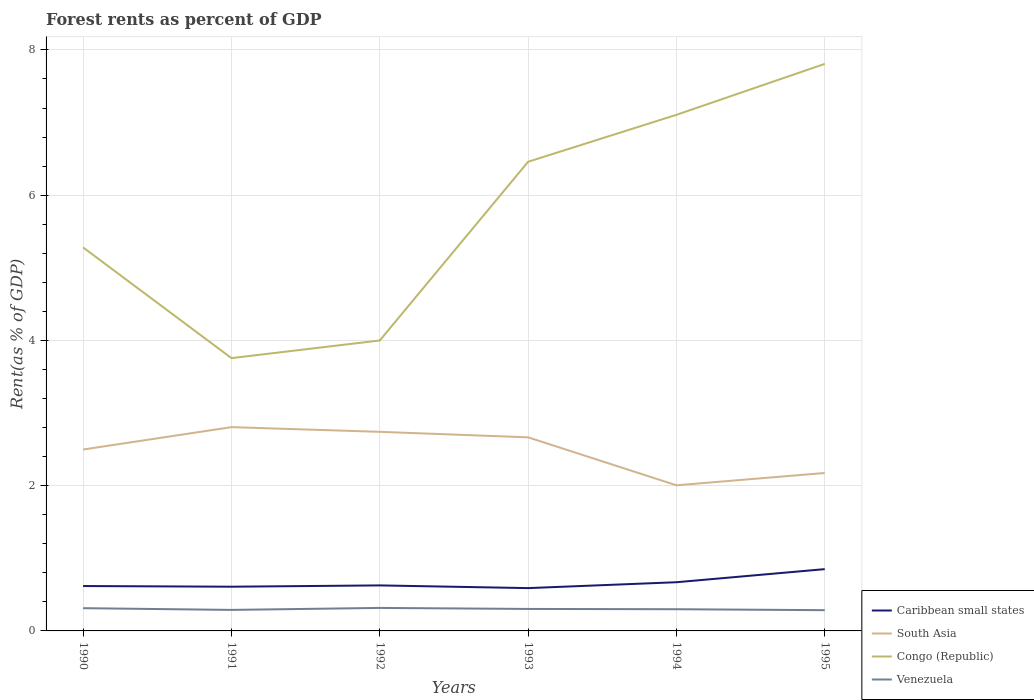How many different coloured lines are there?
Your answer should be compact. 4. Is the number of lines equal to the number of legend labels?
Provide a succinct answer. Yes. Across all years, what is the maximum forest rent in Congo (Republic)?
Make the answer very short. 3.76. What is the total forest rent in Congo (Republic) in the graph?
Ensure brevity in your answer.  -0.65. What is the difference between the highest and the second highest forest rent in Caribbean small states?
Provide a succinct answer. 0.26. How many lines are there?
Offer a terse response. 4. What is the difference between two consecutive major ticks on the Y-axis?
Offer a very short reply. 2. Where does the legend appear in the graph?
Make the answer very short. Bottom right. How many legend labels are there?
Offer a very short reply. 4. What is the title of the graph?
Ensure brevity in your answer.  Forest rents as percent of GDP. Does "Chile" appear as one of the legend labels in the graph?
Give a very brief answer. No. What is the label or title of the Y-axis?
Your answer should be compact. Rent(as % of GDP). What is the Rent(as % of GDP) of Caribbean small states in 1990?
Offer a terse response. 0.62. What is the Rent(as % of GDP) in South Asia in 1990?
Keep it short and to the point. 2.5. What is the Rent(as % of GDP) of Congo (Republic) in 1990?
Give a very brief answer. 5.28. What is the Rent(as % of GDP) in Venezuela in 1990?
Your answer should be compact. 0.31. What is the Rent(as % of GDP) in Caribbean small states in 1991?
Provide a succinct answer. 0.61. What is the Rent(as % of GDP) of South Asia in 1991?
Your response must be concise. 2.81. What is the Rent(as % of GDP) in Congo (Republic) in 1991?
Your answer should be very brief. 3.76. What is the Rent(as % of GDP) of Venezuela in 1991?
Offer a very short reply. 0.29. What is the Rent(as % of GDP) of Caribbean small states in 1992?
Your answer should be very brief. 0.63. What is the Rent(as % of GDP) in South Asia in 1992?
Ensure brevity in your answer.  2.74. What is the Rent(as % of GDP) in Congo (Republic) in 1992?
Make the answer very short. 4. What is the Rent(as % of GDP) of Venezuela in 1992?
Ensure brevity in your answer.  0.32. What is the Rent(as % of GDP) in Caribbean small states in 1993?
Ensure brevity in your answer.  0.59. What is the Rent(as % of GDP) in South Asia in 1993?
Make the answer very short. 2.67. What is the Rent(as % of GDP) of Congo (Republic) in 1993?
Your answer should be compact. 6.46. What is the Rent(as % of GDP) of Venezuela in 1993?
Give a very brief answer. 0.3. What is the Rent(as % of GDP) of Caribbean small states in 1994?
Keep it short and to the point. 0.67. What is the Rent(as % of GDP) in South Asia in 1994?
Offer a very short reply. 2.01. What is the Rent(as % of GDP) of Congo (Republic) in 1994?
Offer a very short reply. 7.11. What is the Rent(as % of GDP) in Venezuela in 1994?
Your response must be concise. 0.3. What is the Rent(as % of GDP) in Caribbean small states in 1995?
Ensure brevity in your answer.  0.85. What is the Rent(as % of GDP) in South Asia in 1995?
Offer a terse response. 2.17. What is the Rent(as % of GDP) of Congo (Republic) in 1995?
Provide a short and direct response. 7.81. What is the Rent(as % of GDP) of Venezuela in 1995?
Make the answer very short. 0.29. Across all years, what is the maximum Rent(as % of GDP) of Caribbean small states?
Ensure brevity in your answer.  0.85. Across all years, what is the maximum Rent(as % of GDP) in South Asia?
Your answer should be compact. 2.81. Across all years, what is the maximum Rent(as % of GDP) in Congo (Republic)?
Your answer should be compact. 7.81. Across all years, what is the maximum Rent(as % of GDP) of Venezuela?
Your answer should be compact. 0.32. Across all years, what is the minimum Rent(as % of GDP) in Caribbean small states?
Make the answer very short. 0.59. Across all years, what is the minimum Rent(as % of GDP) in South Asia?
Make the answer very short. 2.01. Across all years, what is the minimum Rent(as % of GDP) in Congo (Republic)?
Ensure brevity in your answer.  3.76. Across all years, what is the minimum Rent(as % of GDP) of Venezuela?
Offer a terse response. 0.29. What is the total Rent(as % of GDP) of Caribbean small states in the graph?
Give a very brief answer. 3.96. What is the total Rent(as % of GDP) of South Asia in the graph?
Offer a very short reply. 14.89. What is the total Rent(as % of GDP) in Congo (Republic) in the graph?
Offer a very short reply. 34.41. What is the total Rent(as % of GDP) in Venezuela in the graph?
Provide a succinct answer. 1.81. What is the difference between the Rent(as % of GDP) of Caribbean small states in 1990 and that in 1991?
Give a very brief answer. 0.01. What is the difference between the Rent(as % of GDP) of South Asia in 1990 and that in 1991?
Ensure brevity in your answer.  -0.31. What is the difference between the Rent(as % of GDP) of Congo (Republic) in 1990 and that in 1991?
Provide a succinct answer. 1.52. What is the difference between the Rent(as % of GDP) of Venezuela in 1990 and that in 1991?
Provide a succinct answer. 0.02. What is the difference between the Rent(as % of GDP) in Caribbean small states in 1990 and that in 1992?
Provide a succinct answer. -0.01. What is the difference between the Rent(as % of GDP) in South Asia in 1990 and that in 1992?
Keep it short and to the point. -0.24. What is the difference between the Rent(as % of GDP) in Congo (Republic) in 1990 and that in 1992?
Provide a succinct answer. 1.28. What is the difference between the Rent(as % of GDP) in Venezuela in 1990 and that in 1992?
Offer a very short reply. -0. What is the difference between the Rent(as % of GDP) of Caribbean small states in 1990 and that in 1993?
Provide a short and direct response. 0.03. What is the difference between the Rent(as % of GDP) in South Asia in 1990 and that in 1993?
Offer a very short reply. -0.17. What is the difference between the Rent(as % of GDP) in Congo (Republic) in 1990 and that in 1993?
Make the answer very short. -1.18. What is the difference between the Rent(as % of GDP) of Venezuela in 1990 and that in 1993?
Your answer should be compact. 0.01. What is the difference between the Rent(as % of GDP) in Caribbean small states in 1990 and that in 1994?
Your answer should be compact. -0.05. What is the difference between the Rent(as % of GDP) in South Asia in 1990 and that in 1994?
Offer a very short reply. 0.49. What is the difference between the Rent(as % of GDP) of Congo (Republic) in 1990 and that in 1994?
Ensure brevity in your answer.  -1.83. What is the difference between the Rent(as % of GDP) in Venezuela in 1990 and that in 1994?
Your answer should be compact. 0.01. What is the difference between the Rent(as % of GDP) in Caribbean small states in 1990 and that in 1995?
Provide a short and direct response. -0.23. What is the difference between the Rent(as % of GDP) in South Asia in 1990 and that in 1995?
Give a very brief answer. 0.32. What is the difference between the Rent(as % of GDP) of Congo (Republic) in 1990 and that in 1995?
Provide a succinct answer. -2.53. What is the difference between the Rent(as % of GDP) in Venezuela in 1990 and that in 1995?
Provide a succinct answer. 0.03. What is the difference between the Rent(as % of GDP) of Caribbean small states in 1991 and that in 1992?
Your response must be concise. -0.02. What is the difference between the Rent(as % of GDP) of South Asia in 1991 and that in 1992?
Offer a terse response. 0.06. What is the difference between the Rent(as % of GDP) in Congo (Republic) in 1991 and that in 1992?
Your answer should be compact. -0.24. What is the difference between the Rent(as % of GDP) in Venezuela in 1991 and that in 1992?
Provide a succinct answer. -0.03. What is the difference between the Rent(as % of GDP) of Caribbean small states in 1991 and that in 1993?
Offer a terse response. 0.02. What is the difference between the Rent(as % of GDP) in South Asia in 1991 and that in 1993?
Your answer should be very brief. 0.14. What is the difference between the Rent(as % of GDP) in Congo (Republic) in 1991 and that in 1993?
Offer a terse response. -2.7. What is the difference between the Rent(as % of GDP) in Venezuela in 1991 and that in 1993?
Offer a terse response. -0.01. What is the difference between the Rent(as % of GDP) in Caribbean small states in 1991 and that in 1994?
Offer a very short reply. -0.06. What is the difference between the Rent(as % of GDP) in South Asia in 1991 and that in 1994?
Provide a succinct answer. 0.8. What is the difference between the Rent(as % of GDP) in Congo (Republic) in 1991 and that in 1994?
Make the answer very short. -3.35. What is the difference between the Rent(as % of GDP) of Venezuela in 1991 and that in 1994?
Offer a terse response. -0.01. What is the difference between the Rent(as % of GDP) in Caribbean small states in 1991 and that in 1995?
Offer a very short reply. -0.24. What is the difference between the Rent(as % of GDP) in South Asia in 1991 and that in 1995?
Your answer should be compact. 0.63. What is the difference between the Rent(as % of GDP) in Congo (Republic) in 1991 and that in 1995?
Make the answer very short. -4.05. What is the difference between the Rent(as % of GDP) of Venezuela in 1991 and that in 1995?
Provide a succinct answer. 0. What is the difference between the Rent(as % of GDP) of Caribbean small states in 1992 and that in 1993?
Give a very brief answer. 0.04. What is the difference between the Rent(as % of GDP) of South Asia in 1992 and that in 1993?
Make the answer very short. 0.08. What is the difference between the Rent(as % of GDP) of Congo (Republic) in 1992 and that in 1993?
Give a very brief answer. -2.46. What is the difference between the Rent(as % of GDP) in Venezuela in 1992 and that in 1993?
Your answer should be very brief. 0.01. What is the difference between the Rent(as % of GDP) in Caribbean small states in 1992 and that in 1994?
Offer a very short reply. -0.04. What is the difference between the Rent(as % of GDP) of South Asia in 1992 and that in 1994?
Your answer should be compact. 0.74. What is the difference between the Rent(as % of GDP) in Congo (Republic) in 1992 and that in 1994?
Ensure brevity in your answer.  -3.11. What is the difference between the Rent(as % of GDP) of Venezuela in 1992 and that in 1994?
Give a very brief answer. 0.02. What is the difference between the Rent(as % of GDP) of Caribbean small states in 1992 and that in 1995?
Your response must be concise. -0.22. What is the difference between the Rent(as % of GDP) in South Asia in 1992 and that in 1995?
Provide a short and direct response. 0.57. What is the difference between the Rent(as % of GDP) of Congo (Republic) in 1992 and that in 1995?
Offer a terse response. -3.81. What is the difference between the Rent(as % of GDP) in Venezuela in 1992 and that in 1995?
Ensure brevity in your answer.  0.03. What is the difference between the Rent(as % of GDP) of Caribbean small states in 1993 and that in 1994?
Provide a succinct answer. -0.08. What is the difference between the Rent(as % of GDP) in South Asia in 1993 and that in 1994?
Ensure brevity in your answer.  0.66. What is the difference between the Rent(as % of GDP) in Congo (Republic) in 1993 and that in 1994?
Your response must be concise. -0.65. What is the difference between the Rent(as % of GDP) in Venezuela in 1993 and that in 1994?
Offer a terse response. 0. What is the difference between the Rent(as % of GDP) in Caribbean small states in 1993 and that in 1995?
Make the answer very short. -0.26. What is the difference between the Rent(as % of GDP) in South Asia in 1993 and that in 1995?
Provide a succinct answer. 0.49. What is the difference between the Rent(as % of GDP) in Congo (Republic) in 1993 and that in 1995?
Provide a succinct answer. -1.35. What is the difference between the Rent(as % of GDP) in Venezuela in 1993 and that in 1995?
Ensure brevity in your answer.  0.02. What is the difference between the Rent(as % of GDP) of Caribbean small states in 1994 and that in 1995?
Provide a succinct answer. -0.18. What is the difference between the Rent(as % of GDP) of South Asia in 1994 and that in 1995?
Give a very brief answer. -0.17. What is the difference between the Rent(as % of GDP) of Congo (Republic) in 1994 and that in 1995?
Offer a very short reply. -0.7. What is the difference between the Rent(as % of GDP) of Venezuela in 1994 and that in 1995?
Provide a short and direct response. 0.01. What is the difference between the Rent(as % of GDP) in Caribbean small states in 1990 and the Rent(as % of GDP) in South Asia in 1991?
Your answer should be compact. -2.19. What is the difference between the Rent(as % of GDP) of Caribbean small states in 1990 and the Rent(as % of GDP) of Congo (Republic) in 1991?
Give a very brief answer. -3.14. What is the difference between the Rent(as % of GDP) in Caribbean small states in 1990 and the Rent(as % of GDP) in Venezuela in 1991?
Provide a short and direct response. 0.33. What is the difference between the Rent(as % of GDP) in South Asia in 1990 and the Rent(as % of GDP) in Congo (Republic) in 1991?
Offer a very short reply. -1.26. What is the difference between the Rent(as % of GDP) in South Asia in 1990 and the Rent(as % of GDP) in Venezuela in 1991?
Offer a terse response. 2.21. What is the difference between the Rent(as % of GDP) of Congo (Republic) in 1990 and the Rent(as % of GDP) of Venezuela in 1991?
Your response must be concise. 4.99. What is the difference between the Rent(as % of GDP) of Caribbean small states in 1990 and the Rent(as % of GDP) of South Asia in 1992?
Provide a short and direct response. -2.12. What is the difference between the Rent(as % of GDP) in Caribbean small states in 1990 and the Rent(as % of GDP) in Congo (Republic) in 1992?
Offer a terse response. -3.38. What is the difference between the Rent(as % of GDP) in Caribbean small states in 1990 and the Rent(as % of GDP) in Venezuela in 1992?
Your response must be concise. 0.3. What is the difference between the Rent(as % of GDP) of South Asia in 1990 and the Rent(as % of GDP) of Congo (Republic) in 1992?
Make the answer very short. -1.5. What is the difference between the Rent(as % of GDP) in South Asia in 1990 and the Rent(as % of GDP) in Venezuela in 1992?
Offer a terse response. 2.18. What is the difference between the Rent(as % of GDP) of Congo (Republic) in 1990 and the Rent(as % of GDP) of Venezuela in 1992?
Keep it short and to the point. 4.96. What is the difference between the Rent(as % of GDP) of Caribbean small states in 1990 and the Rent(as % of GDP) of South Asia in 1993?
Give a very brief answer. -2.05. What is the difference between the Rent(as % of GDP) of Caribbean small states in 1990 and the Rent(as % of GDP) of Congo (Republic) in 1993?
Keep it short and to the point. -5.84. What is the difference between the Rent(as % of GDP) of Caribbean small states in 1990 and the Rent(as % of GDP) of Venezuela in 1993?
Ensure brevity in your answer.  0.32. What is the difference between the Rent(as % of GDP) in South Asia in 1990 and the Rent(as % of GDP) in Congo (Republic) in 1993?
Your answer should be very brief. -3.96. What is the difference between the Rent(as % of GDP) in South Asia in 1990 and the Rent(as % of GDP) in Venezuela in 1993?
Offer a terse response. 2.2. What is the difference between the Rent(as % of GDP) of Congo (Republic) in 1990 and the Rent(as % of GDP) of Venezuela in 1993?
Offer a terse response. 4.98. What is the difference between the Rent(as % of GDP) of Caribbean small states in 1990 and the Rent(as % of GDP) of South Asia in 1994?
Your answer should be compact. -1.39. What is the difference between the Rent(as % of GDP) in Caribbean small states in 1990 and the Rent(as % of GDP) in Congo (Republic) in 1994?
Offer a very short reply. -6.49. What is the difference between the Rent(as % of GDP) in Caribbean small states in 1990 and the Rent(as % of GDP) in Venezuela in 1994?
Your answer should be compact. 0.32. What is the difference between the Rent(as % of GDP) of South Asia in 1990 and the Rent(as % of GDP) of Congo (Republic) in 1994?
Your answer should be very brief. -4.61. What is the difference between the Rent(as % of GDP) of South Asia in 1990 and the Rent(as % of GDP) of Venezuela in 1994?
Make the answer very short. 2.2. What is the difference between the Rent(as % of GDP) of Congo (Republic) in 1990 and the Rent(as % of GDP) of Venezuela in 1994?
Your answer should be compact. 4.98. What is the difference between the Rent(as % of GDP) in Caribbean small states in 1990 and the Rent(as % of GDP) in South Asia in 1995?
Give a very brief answer. -1.56. What is the difference between the Rent(as % of GDP) of Caribbean small states in 1990 and the Rent(as % of GDP) of Congo (Republic) in 1995?
Make the answer very short. -7.19. What is the difference between the Rent(as % of GDP) of Caribbean small states in 1990 and the Rent(as % of GDP) of Venezuela in 1995?
Offer a terse response. 0.33. What is the difference between the Rent(as % of GDP) of South Asia in 1990 and the Rent(as % of GDP) of Congo (Republic) in 1995?
Your response must be concise. -5.31. What is the difference between the Rent(as % of GDP) in South Asia in 1990 and the Rent(as % of GDP) in Venezuela in 1995?
Make the answer very short. 2.21. What is the difference between the Rent(as % of GDP) in Congo (Republic) in 1990 and the Rent(as % of GDP) in Venezuela in 1995?
Your answer should be compact. 4.99. What is the difference between the Rent(as % of GDP) of Caribbean small states in 1991 and the Rent(as % of GDP) of South Asia in 1992?
Provide a short and direct response. -2.13. What is the difference between the Rent(as % of GDP) in Caribbean small states in 1991 and the Rent(as % of GDP) in Congo (Republic) in 1992?
Give a very brief answer. -3.39. What is the difference between the Rent(as % of GDP) of Caribbean small states in 1991 and the Rent(as % of GDP) of Venezuela in 1992?
Provide a succinct answer. 0.29. What is the difference between the Rent(as % of GDP) in South Asia in 1991 and the Rent(as % of GDP) in Congo (Republic) in 1992?
Keep it short and to the point. -1.19. What is the difference between the Rent(as % of GDP) in South Asia in 1991 and the Rent(as % of GDP) in Venezuela in 1992?
Your answer should be compact. 2.49. What is the difference between the Rent(as % of GDP) in Congo (Republic) in 1991 and the Rent(as % of GDP) in Venezuela in 1992?
Your response must be concise. 3.44. What is the difference between the Rent(as % of GDP) of Caribbean small states in 1991 and the Rent(as % of GDP) of South Asia in 1993?
Ensure brevity in your answer.  -2.06. What is the difference between the Rent(as % of GDP) in Caribbean small states in 1991 and the Rent(as % of GDP) in Congo (Republic) in 1993?
Your answer should be very brief. -5.85. What is the difference between the Rent(as % of GDP) of Caribbean small states in 1991 and the Rent(as % of GDP) of Venezuela in 1993?
Provide a succinct answer. 0.31. What is the difference between the Rent(as % of GDP) of South Asia in 1991 and the Rent(as % of GDP) of Congo (Republic) in 1993?
Give a very brief answer. -3.65. What is the difference between the Rent(as % of GDP) in South Asia in 1991 and the Rent(as % of GDP) in Venezuela in 1993?
Provide a short and direct response. 2.5. What is the difference between the Rent(as % of GDP) of Congo (Republic) in 1991 and the Rent(as % of GDP) of Venezuela in 1993?
Keep it short and to the point. 3.45. What is the difference between the Rent(as % of GDP) of Caribbean small states in 1991 and the Rent(as % of GDP) of South Asia in 1994?
Your answer should be very brief. -1.4. What is the difference between the Rent(as % of GDP) of Caribbean small states in 1991 and the Rent(as % of GDP) of Congo (Republic) in 1994?
Provide a short and direct response. -6.5. What is the difference between the Rent(as % of GDP) of Caribbean small states in 1991 and the Rent(as % of GDP) of Venezuela in 1994?
Your answer should be very brief. 0.31. What is the difference between the Rent(as % of GDP) in South Asia in 1991 and the Rent(as % of GDP) in Congo (Republic) in 1994?
Provide a short and direct response. -4.3. What is the difference between the Rent(as % of GDP) of South Asia in 1991 and the Rent(as % of GDP) of Venezuela in 1994?
Make the answer very short. 2.51. What is the difference between the Rent(as % of GDP) of Congo (Republic) in 1991 and the Rent(as % of GDP) of Venezuela in 1994?
Your answer should be compact. 3.46. What is the difference between the Rent(as % of GDP) of Caribbean small states in 1991 and the Rent(as % of GDP) of South Asia in 1995?
Offer a very short reply. -1.57. What is the difference between the Rent(as % of GDP) of Caribbean small states in 1991 and the Rent(as % of GDP) of Congo (Republic) in 1995?
Your answer should be very brief. -7.2. What is the difference between the Rent(as % of GDP) in Caribbean small states in 1991 and the Rent(as % of GDP) in Venezuela in 1995?
Offer a terse response. 0.32. What is the difference between the Rent(as % of GDP) of South Asia in 1991 and the Rent(as % of GDP) of Congo (Republic) in 1995?
Make the answer very short. -5. What is the difference between the Rent(as % of GDP) of South Asia in 1991 and the Rent(as % of GDP) of Venezuela in 1995?
Give a very brief answer. 2.52. What is the difference between the Rent(as % of GDP) in Congo (Republic) in 1991 and the Rent(as % of GDP) in Venezuela in 1995?
Make the answer very short. 3.47. What is the difference between the Rent(as % of GDP) of Caribbean small states in 1992 and the Rent(as % of GDP) of South Asia in 1993?
Give a very brief answer. -2.04. What is the difference between the Rent(as % of GDP) of Caribbean small states in 1992 and the Rent(as % of GDP) of Congo (Republic) in 1993?
Offer a terse response. -5.83. What is the difference between the Rent(as % of GDP) of Caribbean small states in 1992 and the Rent(as % of GDP) of Venezuela in 1993?
Your answer should be very brief. 0.32. What is the difference between the Rent(as % of GDP) in South Asia in 1992 and the Rent(as % of GDP) in Congo (Republic) in 1993?
Give a very brief answer. -3.72. What is the difference between the Rent(as % of GDP) of South Asia in 1992 and the Rent(as % of GDP) of Venezuela in 1993?
Your answer should be very brief. 2.44. What is the difference between the Rent(as % of GDP) of Congo (Republic) in 1992 and the Rent(as % of GDP) of Venezuela in 1993?
Give a very brief answer. 3.7. What is the difference between the Rent(as % of GDP) of Caribbean small states in 1992 and the Rent(as % of GDP) of South Asia in 1994?
Provide a short and direct response. -1.38. What is the difference between the Rent(as % of GDP) in Caribbean small states in 1992 and the Rent(as % of GDP) in Congo (Republic) in 1994?
Provide a succinct answer. -6.48. What is the difference between the Rent(as % of GDP) of Caribbean small states in 1992 and the Rent(as % of GDP) of Venezuela in 1994?
Keep it short and to the point. 0.33. What is the difference between the Rent(as % of GDP) of South Asia in 1992 and the Rent(as % of GDP) of Congo (Republic) in 1994?
Provide a succinct answer. -4.37. What is the difference between the Rent(as % of GDP) in South Asia in 1992 and the Rent(as % of GDP) in Venezuela in 1994?
Your response must be concise. 2.44. What is the difference between the Rent(as % of GDP) in Congo (Republic) in 1992 and the Rent(as % of GDP) in Venezuela in 1994?
Offer a terse response. 3.7. What is the difference between the Rent(as % of GDP) in Caribbean small states in 1992 and the Rent(as % of GDP) in South Asia in 1995?
Give a very brief answer. -1.55. What is the difference between the Rent(as % of GDP) of Caribbean small states in 1992 and the Rent(as % of GDP) of Congo (Republic) in 1995?
Your answer should be very brief. -7.18. What is the difference between the Rent(as % of GDP) of Caribbean small states in 1992 and the Rent(as % of GDP) of Venezuela in 1995?
Your response must be concise. 0.34. What is the difference between the Rent(as % of GDP) in South Asia in 1992 and the Rent(as % of GDP) in Congo (Republic) in 1995?
Your answer should be compact. -5.07. What is the difference between the Rent(as % of GDP) of South Asia in 1992 and the Rent(as % of GDP) of Venezuela in 1995?
Offer a very short reply. 2.46. What is the difference between the Rent(as % of GDP) in Congo (Republic) in 1992 and the Rent(as % of GDP) in Venezuela in 1995?
Ensure brevity in your answer.  3.71. What is the difference between the Rent(as % of GDP) of Caribbean small states in 1993 and the Rent(as % of GDP) of South Asia in 1994?
Provide a succinct answer. -1.42. What is the difference between the Rent(as % of GDP) of Caribbean small states in 1993 and the Rent(as % of GDP) of Congo (Republic) in 1994?
Give a very brief answer. -6.52. What is the difference between the Rent(as % of GDP) in Caribbean small states in 1993 and the Rent(as % of GDP) in Venezuela in 1994?
Give a very brief answer. 0.29. What is the difference between the Rent(as % of GDP) in South Asia in 1993 and the Rent(as % of GDP) in Congo (Republic) in 1994?
Your response must be concise. -4.44. What is the difference between the Rent(as % of GDP) in South Asia in 1993 and the Rent(as % of GDP) in Venezuela in 1994?
Provide a short and direct response. 2.37. What is the difference between the Rent(as % of GDP) of Congo (Republic) in 1993 and the Rent(as % of GDP) of Venezuela in 1994?
Your answer should be very brief. 6.16. What is the difference between the Rent(as % of GDP) in Caribbean small states in 1993 and the Rent(as % of GDP) in South Asia in 1995?
Your answer should be compact. -1.59. What is the difference between the Rent(as % of GDP) in Caribbean small states in 1993 and the Rent(as % of GDP) in Congo (Republic) in 1995?
Keep it short and to the point. -7.22. What is the difference between the Rent(as % of GDP) in Caribbean small states in 1993 and the Rent(as % of GDP) in Venezuela in 1995?
Your answer should be compact. 0.3. What is the difference between the Rent(as % of GDP) of South Asia in 1993 and the Rent(as % of GDP) of Congo (Republic) in 1995?
Your answer should be very brief. -5.14. What is the difference between the Rent(as % of GDP) in South Asia in 1993 and the Rent(as % of GDP) in Venezuela in 1995?
Provide a short and direct response. 2.38. What is the difference between the Rent(as % of GDP) in Congo (Republic) in 1993 and the Rent(as % of GDP) in Venezuela in 1995?
Keep it short and to the point. 6.17. What is the difference between the Rent(as % of GDP) of Caribbean small states in 1994 and the Rent(as % of GDP) of South Asia in 1995?
Ensure brevity in your answer.  -1.5. What is the difference between the Rent(as % of GDP) in Caribbean small states in 1994 and the Rent(as % of GDP) in Congo (Republic) in 1995?
Your answer should be very brief. -7.14. What is the difference between the Rent(as % of GDP) in Caribbean small states in 1994 and the Rent(as % of GDP) in Venezuela in 1995?
Provide a succinct answer. 0.38. What is the difference between the Rent(as % of GDP) in South Asia in 1994 and the Rent(as % of GDP) in Congo (Republic) in 1995?
Offer a terse response. -5.8. What is the difference between the Rent(as % of GDP) in South Asia in 1994 and the Rent(as % of GDP) in Venezuela in 1995?
Offer a terse response. 1.72. What is the difference between the Rent(as % of GDP) in Congo (Republic) in 1994 and the Rent(as % of GDP) in Venezuela in 1995?
Make the answer very short. 6.82. What is the average Rent(as % of GDP) of Caribbean small states per year?
Provide a short and direct response. 0.66. What is the average Rent(as % of GDP) of South Asia per year?
Keep it short and to the point. 2.48. What is the average Rent(as % of GDP) of Congo (Republic) per year?
Provide a succinct answer. 5.74. What is the average Rent(as % of GDP) in Venezuela per year?
Your response must be concise. 0.3. In the year 1990, what is the difference between the Rent(as % of GDP) of Caribbean small states and Rent(as % of GDP) of South Asia?
Keep it short and to the point. -1.88. In the year 1990, what is the difference between the Rent(as % of GDP) in Caribbean small states and Rent(as % of GDP) in Congo (Republic)?
Give a very brief answer. -4.66. In the year 1990, what is the difference between the Rent(as % of GDP) in Caribbean small states and Rent(as % of GDP) in Venezuela?
Make the answer very short. 0.3. In the year 1990, what is the difference between the Rent(as % of GDP) of South Asia and Rent(as % of GDP) of Congo (Republic)?
Provide a succinct answer. -2.78. In the year 1990, what is the difference between the Rent(as % of GDP) in South Asia and Rent(as % of GDP) in Venezuela?
Provide a short and direct response. 2.18. In the year 1990, what is the difference between the Rent(as % of GDP) of Congo (Republic) and Rent(as % of GDP) of Venezuela?
Your answer should be compact. 4.97. In the year 1991, what is the difference between the Rent(as % of GDP) of Caribbean small states and Rent(as % of GDP) of South Asia?
Your answer should be very brief. -2.2. In the year 1991, what is the difference between the Rent(as % of GDP) in Caribbean small states and Rent(as % of GDP) in Congo (Republic)?
Give a very brief answer. -3.15. In the year 1991, what is the difference between the Rent(as % of GDP) of Caribbean small states and Rent(as % of GDP) of Venezuela?
Your answer should be very brief. 0.32. In the year 1991, what is the difference between the Rent(as % of GDP) of South Asia and Rent(as % of GDP) of Congo (Republic)?
Offer a terse response. -0.95. In the year 1991, what is the difference between the Rent(as % of GDP) of South Asia and Rent(as % of GDP) of Venezuela?
Provide a succinct answer. 2.52. In the year 1991, what is the difference between the Rent(as % of GDP) of Congo (Republic) and Rent(as % of GDP) of Venezuela?
Your answer should be compact. 3.47. In the year 1992, what is the difference between the Rent(as % of GDP) in Caribbean small states and Rent(as % of GDP) in South Asia?
Your answer should be very brief. -2.11. In the year 1992, what is the difference between the Rent(as % of GDP) of Caribbean small states and Rent(as % of GDP) of Congo (Republic)?
Provide a succinct answer. -3.37. In the year 1992, what is the difference between the Rent(as % of GDP) of Caribbean small states and Rent(as % of GDP) of Venezuela?
Offer a very short reply. 0.31. In the year 1992, what is the difference between the Rent(as % of GDP) in South Asia and Rent(as % of GDP) in Congo (Republic)?
Your answer should be very brief. -1.26. In the year 1992, what is the difference between the Rent(as % of GDP) in South Asia and Rent(as % of GDP) in Venezuela?
Your answer should be compact. 2.42. In the year 1992, what is the difference between the Rent(as % of GDP) of Congo (Republic) and Rent(as % of GDP) of Venezuela?
Give a very brief answer. 3.68. In the year 1993, what is the difference between the Rent(as % of GDP) in Caribbean small states and Rent(as % of GDP) in South Asia?
Give a very brief answer. -2.08. In the year 1993, what is the difference between the Rent(as % of GDP) in Caribbean small states and Rent(as % of GDP) in Congo (Republic)?
Your answer should be very brief. -5.87. In the year 1993, what is the difference between the Rent(as % of GDP) of Caribbean small states and Rent(as % of GDP) of Venezuela?
Ensure brevity in your answer.  0.29. In the year 1993, what is the difference between the Rent(as % of GDP) in South Asia and Rent(as % of GDP) in Congo (Republic)?
Your answer should be very brief. -3.79. In the year 1993, what is the difference between the Rent(as % of GDP) in South Asia and Rent(as % of GDP) in Venezuela?
Make the answer very short. 2.36. In the year 1993, what is the difference between the Rent(as % of GDP) in Congo (Republic) and Rent(as % of GDP) in Venezuela?
Provide a short and direct response. 6.16. In the year 1994, what is the difference between the Rent(as % of GDP) of Caribbean small states and Rent(as % of GDP) of South Asia?
Your answer should be compact. -1.33. In the year 1994, what is the difference between the Rent(as % of GDP) in Caribbean small states and Rent(as % of GDP) in Congo (Republic)?
Your response must be concise. -6.44. In the year 1994, what is the difference between the Rent(as % of GDP) in Caribbean small states and Rent(as % of GDP) in Venezuela?
Offer a very short reply. 0.37. In the year 1994, what is the difference between the Rent(as % of GDP) of South Asia and Rent(as % of GDP) of Congo (Republic)?
Provide a succinct answer. -5.1. In the year 1994, what is the difference between the Rent(as % of GDP) of South Asia and Rent(as % of GDP) of Venezuela?
Ensure brevity in your answer.  1.71. In the year 1994, what is the difference between the Rent(as % of GDP) in Congo (Republic) and Rent(as % of GDP) in Venezuela?
Your answer should be very brief. 6.81. In the year 1995, what is the difference between the Rent(as % of GDP) in Caribbean small states and Rent(as % of GDP) in South Asia?
Your answer should be very brief. -1.32. In the year 1995, what is the difference between the Rent(as % of GDP) of Caribbean small states and Rent(as % of GDP) of Congo (Republic)?
Give a very brief answer. -6.96. In the year 1995, what is the difference between the Rent(as % of GDP) of Caribbean small states and Rent(as % of GDP) of Venezuela?
Give a very brief answer. 0.56. In the year 1995, what is the difference between the Rent(as % of GDP) of South Asia and Rent(as % of GDP) of Congo (Republic)?
Provide a succinct answer. -5.63. In the year 1995, what is the difference between the Rent(as % of GDP) of South Asia and Rent(as % of GDP) of Venezuela?
Your answer should be compact. 1.89. In the year 1995, what is the difference between the Rent(as % of GDP) in Congo (Republic) and Rent(as % of GDP) in Venezuela?
Offer a terse response. 7.52. What is the ratio of the Rent(as % of GDP) of Caribbean small states in 1990 to that in 1991?
Ensure brevity in your answer.  1.02. What is the ratio of the Rent(as % of GDP) in South Asia in 1990 to that in 1991?
Provide a succinct answer. 0.89. What is the ratio of the Rent(as % of GDP) in Congo (Republic) in 1990 to that in 1991?
Provide a succinct answer. 1.41. What is the ratio of the Rent(as % of GDP) in Venezuela in 1990 to that in 1991?
Give a very brief answer. 1.08. What is the ratio of the Rent(as % of GDP) of Caribbean small states in 1990 to that in 1992?
Offer a very short reply. 0.99. What is the ratio of the Rent(as % of GDP) in South Asia in 1990 to that in 1992?
Provide a short and direct response. 0.91. What is the ratio of the Rent(as % of GDP) in Congo (Republic) in 1990 to that in 1992?
Your answer should be very brief. 1.32. What is the ratio of the Rent(as % of GDP) in Caribbean small states in 1990 to that in 1993?
Provide a short and direct response. 1.05. What is the ratio of the Rent(as % of GDP) of South Asia in 1990 to that in 1993?
Your response must be concise. 0.94. What is the ratio of the Rent(as % of GDP) of Congo (Republic) in 1990 to that in 1993?
Make the answer very short. 0.82. What is the ratio of the Rent(as % of GDP) of Venezuela in 1990 to that in 1993?
Keep it short and to the point. 1.03. What is the ratio of the Rent(as % of GDP) of Caribbean small states in 1990 to that in 1994?
Your answer should be very brief. 0.92. What is the ratio of the Rent(as % of GDP) in South Asia in 1990 to that in 1994?
Your answer should be very brief. 1.25. What is the ratio of the Rent(as % of GDP) in Congo (Republic) in 1990 to that in 1994?
Keep it short and to the point. 0.74. What is the ratio of the Rent(as % of GDP) in Venezuela in 1990 to that in 1994?
Offer a terse response. 1.05. What is the ratio of the Rent(as % of GDP) in Caribbean small states in 1990 to that in 1995?
Offer a terse response. 0.73. What is the ratio of the Rent(as % of GDP) of South Asia in 1990 to that in 1995?
Offer a terse response. 1.15. What is the ratio of the Rent(as % of GDP) of Congo (Republic) in 1990 to that in 1995?
Provide a succinct answer. 0.68. What is the ratio of the Rent(as % of GDP) in Venezuela in 1990 to that in 1995?
Your response must be concise. 1.1. What is the ratio of the Rent(as % of GDP) of Caribbean small states in 1991 to that in 1992?
Make the answer very short. 0.97. What is the ratio of the Rent(as % of GDP) of South Asia in 1991 to that in 1992?
Make the answer very short. 1.02. What is the ratio of the Rent(as % of GDP) of Congo (Republic) in 1991 to that in 1992?
Make the answer very short. 0.94. What is the ratio of the Rent(as % of GDP) in Venezuela in 1991 to that in 1992?
Provide a succinct answer. 0.91. What is the ratio of the Rent(as % of GDP) of Caribbean small states in 1991 to that in 1993?
Your response must be concise. 1.03. What is the ratio of the Rent(as % of GDP) in South Asia in 1991 to that in 1993?
Your response must be concise. 1.05. What is the ratio of the Rent(as % of GDP) of Congo (Republic) in 1991 to that in 1993?
Provide a succinct answer. 0.58. What is the ratio of the Rent(as % of GDP) of Venezuela in 1991 to that in 1993?
Give a very brief answer. 0.96. What is the ratio of the Rent(as % of GDP) of Caribbean small states in 1991 to that in 1994?
Your response must be concise. 0.91. What is the ratio of the Rent(as % of GDP) of South Asia in 1991 to that in 1994?
Give a very brief answer. 1.4. What is the ratio of the Rent(as % of GDP) of Congo (Republic) in 1991 to that in 1994?
Your response must be concise. 0.53. What is the ratio of the Rent(as % of GDP) in Caribbean small states in 1991 to that in 1995?
Your answer should be very brief. 0.72. What is the ratio of the Rent(as % of GDP) of South Asia in 1991 to that in 1995?
Your answer should be compact. 1.29. What is the ratio of the Rent(as % of GDP) in Congo (Republic) in 1991 to that in 1995?
Ensure brevity in your answer.  0.48. What is the ratio of the Rent(as % of GDP) in Venezuela in 1991 to that in 1995?
Offer a very short reply. 1.01. What is the ratio of the Rent(as % of GDP) in Caribbean small states in 1992 to that in 1993?
Provide a short and direct response. 1.06. What is the ratio of the Rent(as % of GDP) in South Asia in 1992 to that in 1993?
Provide a succinct answer. 1.03. What is the ratio of the Rent(as % of GDP) in Congo (Republic) in 1992 to that in 1993?
Keep it short and to the point. 0.62. What is the ratio of the Rent(as % of GDP) of Venezuela in 1992 to that in 1993?
Give a very brief answer. 1.05. What is the ratio of the Rent(as % of GDP) of Caribbean small states in 1992 to that in 1994?
Keep it short and to the point. 0.93. What is the ratio of the Rent(as % of GDP) in South Asia in 1992 to that in 1994?
Offer a very short reply. 1.37. What is the ratio of the Rent(as % of GDP) in Congo (Republic) in 1992 to that in 1994?
Provide a succinct answer. 0.56. What is the ratio of the Rent(as % of GDP) of Venezuela in 1992 to that in 1994?
Your answer should be very brief. 1.06. What is the ratio of the Rent(as % of GDP) in Caribbean small states in 1992 to that in 1995?
Provide a succinct answer. 0.74. What is the ratio of the Rent(as % of GDP) of South Asia in 1992 to that in 1995?
Your response must be concise. 1.26. What is the ratio of the Rent(as % of GDP) in Congo (Republic) in 1992 to that in 1995?
Provide a succinct answer. 0.51. What is the ratio of the Rent(as % of GDP) of Venezuela in 1992 to that in 1995?
Make the answer very short. 1.11. What is the ratio of the Rent(as % of GDP) in Caribbean small states in 1993 to that in 1994?
Ensure brevity in your answer.  0.88. What is the ratio of the Rent(as % of GDP) in South Asia in 1993 to that in 1994?
Offer a very short reply. 1.33. What is the ratio of the Rent(as % of GDP) of Congo (Republic) in 1993 to that in 1994?
Your answer should be compact. 0.91. What is the ratio of the Rent(as % of GDP) of Venezuela in 1993 to that in 1994?
Your response must be concise. 1.01. What is the ratio of the Rent(as % of GDP) in Caribbean small states in 1993 to that in 1995?
Offer a very short reply. 0.69. What is the ratio of the Rent(as % of GDP) of South Asia in 1993 to that in 1995?
Offer a very short reply. 1.23. What is the ratio of the Rent(as % of GDP) in Congo (Republic) in 1993 to that in 1995?
Provide a short and direct response. 0.83. What is the ratio of the Rent(as % of GDP) in Venezuela in 1993 to that in 1995?
Provide a succinct answer. 1.06. What is the ratio of the Rent(as % of GDP) in Caribbean small states in 1994 to that in 1995?
Give a very brief answer. 0.79. What is the ratio of the Rent(as % of GDP) of South Asia in 1994 to that in 1995?
Ensure brevity in your answer.  0.92. What is the ratio of the Rent(as % of GDP) of Congo (Republic) in 1994 to that in 1995?
Ensure brevity in your answer.  0.91. What is the ratio of the Rent(as % of GDP) of Venezuela in 1994 to that in 1995?
Keep it short and to the point. 1.05. What is the difference between the highest and the second highest Rent(as % of GDP) of Caribbean small states?
Offer a terse response. 0.18. What is the difference between the highest and the second highest Rent(as % of GDP) in South Asia?
Offer a terse response. 0.06. What is the difference between the highest and the second highest Rent(as % of GDP) of Congo (Republic)?
Provide a succinct answer. 0.7. What is the difference between the highest and the second highest Rent(as % of GDP) in Venezuela?
Offer a terse response. 0. What is the difference between the highest and the lowest Rent(as % of GDP) of Caribbean small states?
Your answer should be compact. 0.26. What is the difference between the highest and the lowest Rent(as % of GDP) of South Asia?
Your answer should be very brief. 0.8. What is the difference between the highest and the lowest Rent(as % of GDP) in Congo (Republic)?
Ensure brevity in your answer.  4.05. What is the difference between the highest and the lowest Rent(as % of GDP) of Venezuela?
Provide a short and direct response. 0.03. 